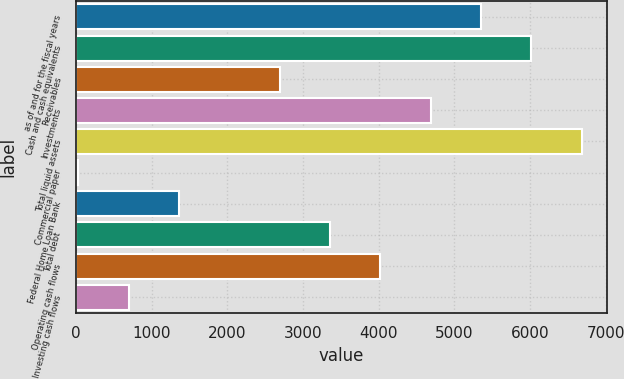<chart> <loc_0><loc_0><loc_500><loc_500><bar_chart><fcel>as of and for the fiscal years<fcel>Cash and cash equivalents<fcel>Receivables<fcel>Investments<fcel>Total liquid assets<fcel>Commercial paper<fcel>Federal Home Loan Bank<fcel>Total debt<fcel>Operating cash flows<fcel>Investing cash flows<nl><fcel>5353.28<fcel>6018.69<fcel>2691.64<fcel>4687.87<fcel>6684.1<fcel>30<fcel>1360.82<fcel>3357.05<fcel>4022.46<fcel>695.41<nl></chart> 